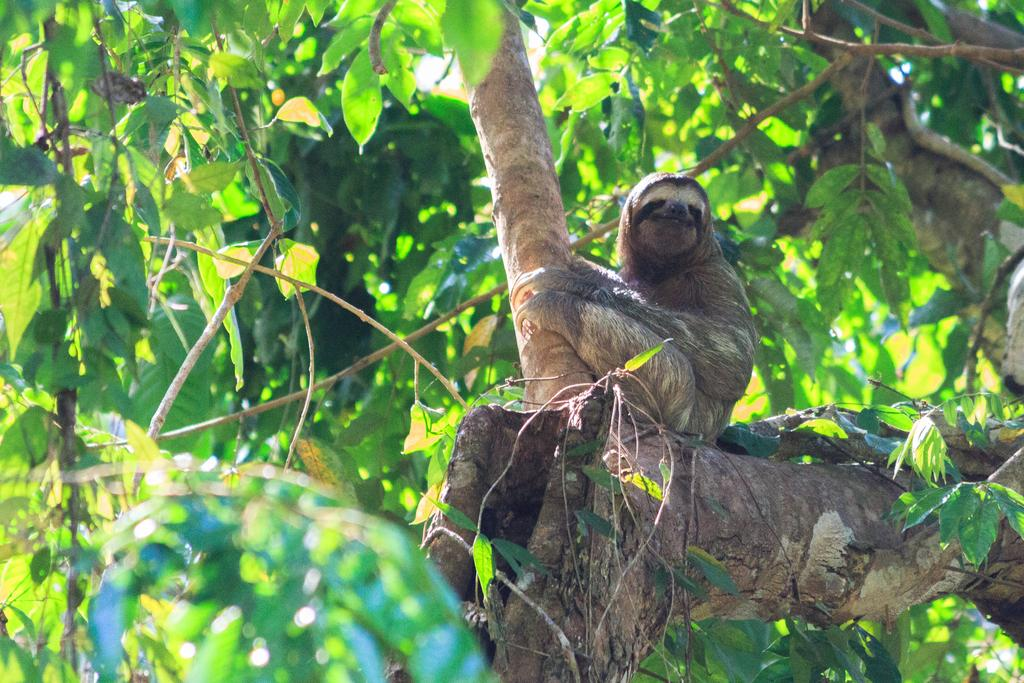What type of animal can be seen in the picture? There is an animal in the picture, but its specific type cannot be determined from the provided facts. Where is the animal located in the picture? The animal is sitting on a tree in the picture. What is the color of the animal? The animal is brown in color. What can be seen in the background of the picture? There is a tree in the background of the picture. What type of meal is the animal eating in the picture? There is no meal present in the picture, and the animal's actions cannot be determined from the provided facts. What sound does the animal make in the picture? The sound the animal makes cannot be determined from the provided facts, as the image is silent. 